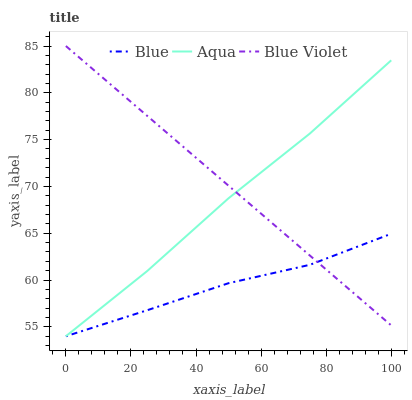Does Blue have the minimum area under the curve?
Answer yes or no. Yes. Does Blue Violet have the maximum area under the curve?
Answer yes or no. Yes. Does Aqua have the minimum area under the curve?
Answer yes or no. No. Does Aqua have the maximum area under the curve?
Answer yes or no. No. Is Blue Violet the smoothest?
Answer yes or no. Yes. Is Aqua the roughest?
Answer yes or no. Yes. Is Aqua the smoothest?
Answer yes or no. No. Is Blue Violet the roughest?
Answer yes or no. No. Does Blue have the lowest value?
Answer yes or no. Yes. Does Blue Violet have the lowest value?
Answer yes or no. No. Does Blue Violet have the highest value?
Answer yes or no. Yes. Does Aqua have the highest value?
Answer yes or no. No. Does Aqua intersect Blue?
Answer yes or no. Yes. Is Aqua less than Blue?
Answer yes or no. No. Is Aqua greater than Blue?
Answer yes or no. No. 